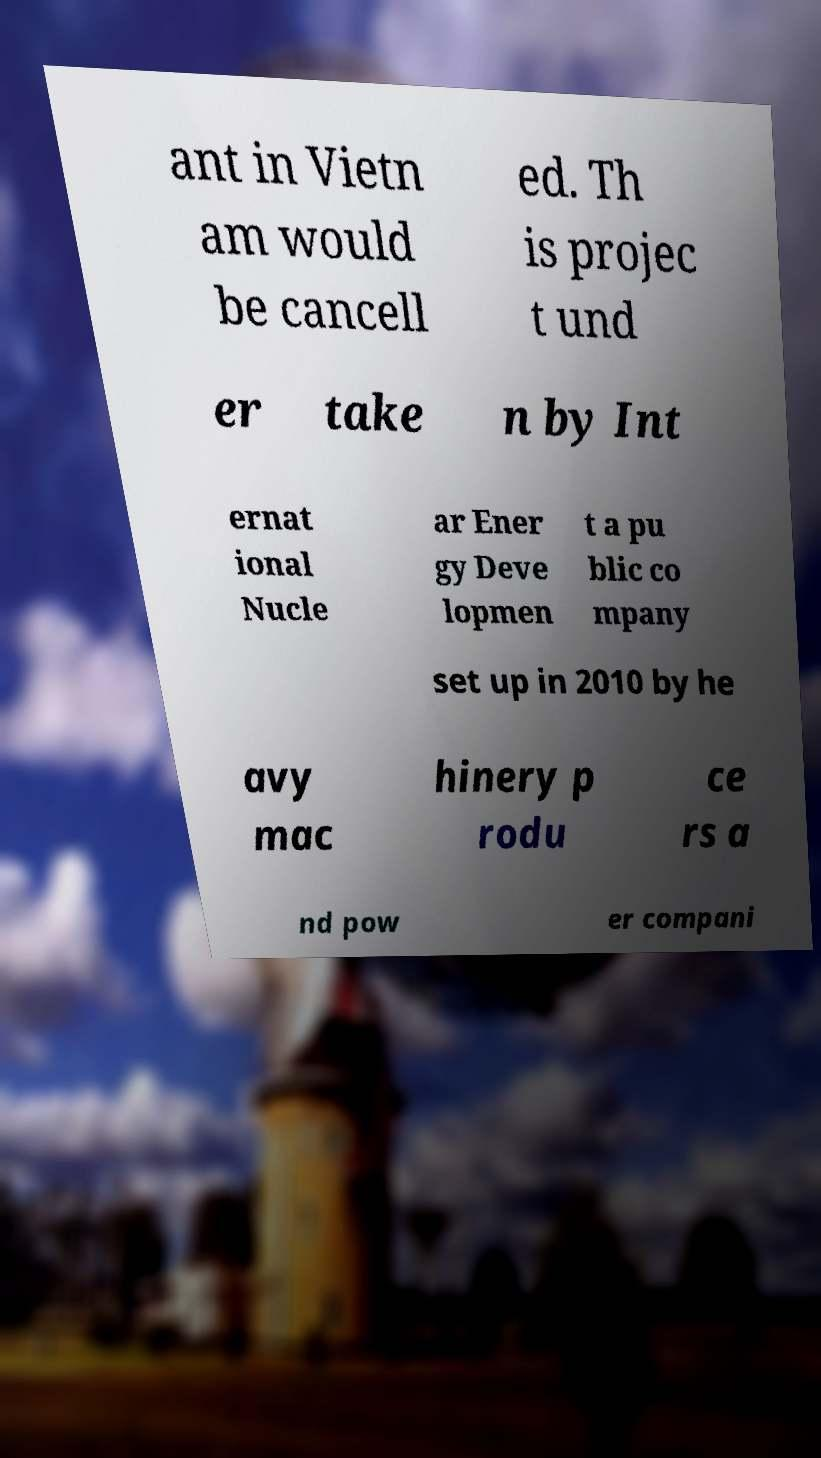Could you extract and type out the text from this image? ant in Vietn am would be cancell ed. Th is projec t und er take n by Int ernat ional Nucle ar Ener gy Deve lopmen t a pu blic co mpany set up in 2010 by he avy mac hinery p rodu ce rs a nd pow er compani 